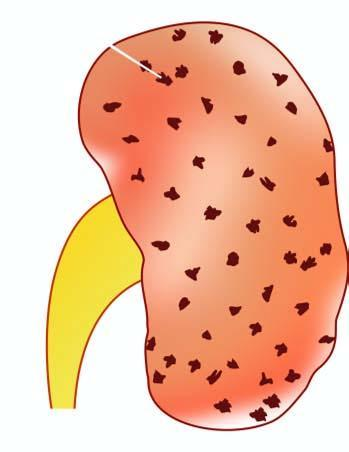what is enlarged in size and weight?
Answer the question using a single word or phrase. Kidney 